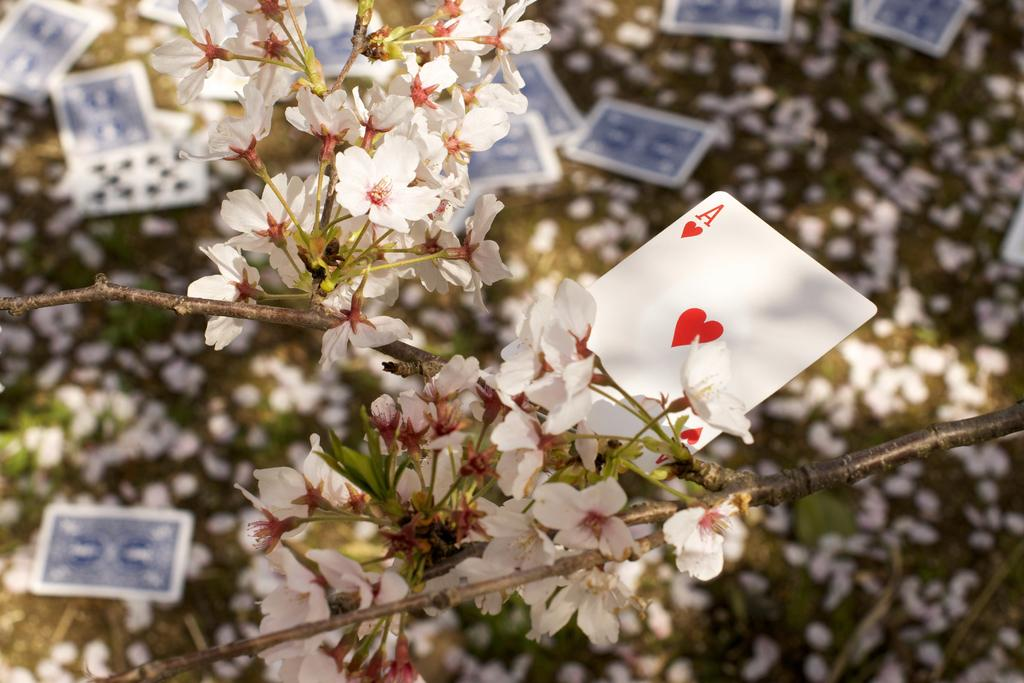What is placed on the white flowers in the image? There is a card on some white flowers in the image. Are there any other cards visible in the image? Yes, there are additional cards visible in the image. What can be seen on the path in the image? There are white petals on the path in the image. What is the distance between the roof and the trail in the image? There is no roof or trail present in the image, so it is not possible to determine the distance between them. 